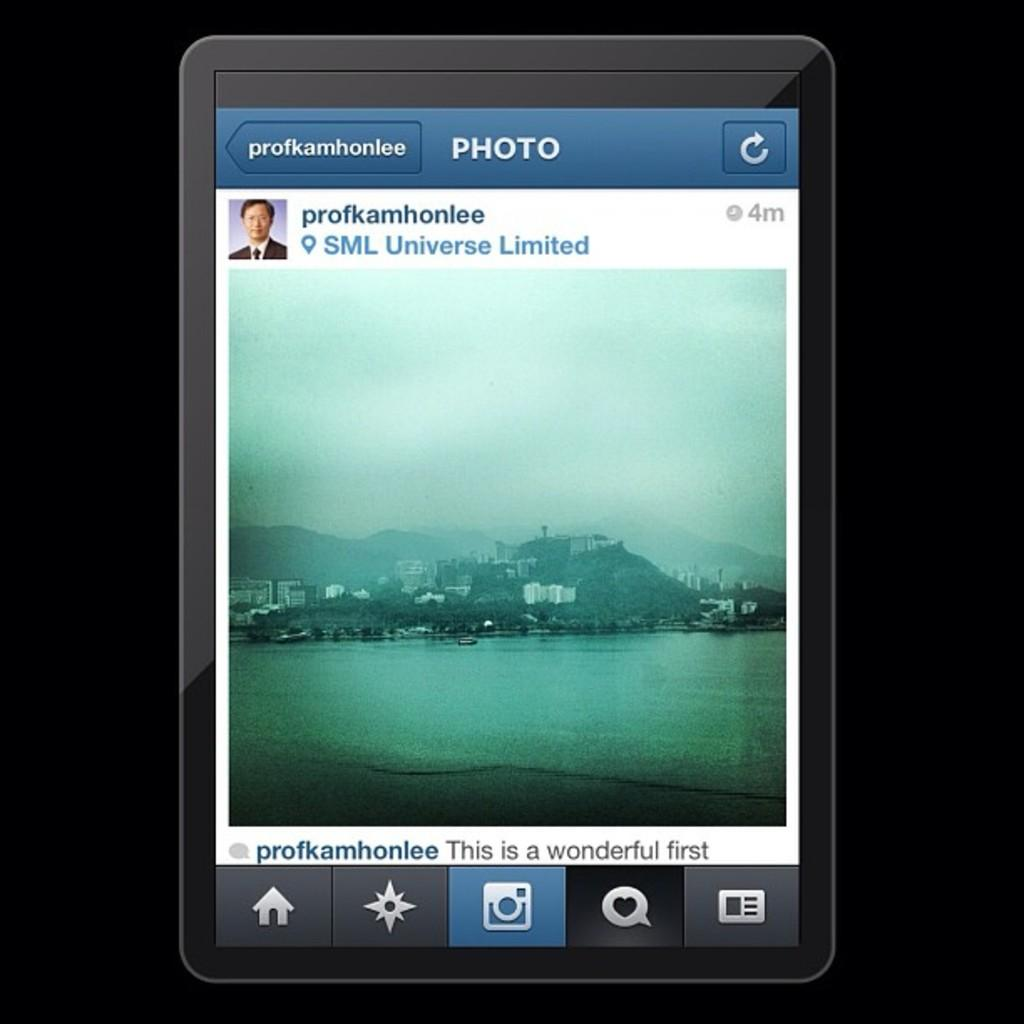<image>
Render a clear and concise summary of the photo. A social media post showing a photo by user profkamhonlee. 